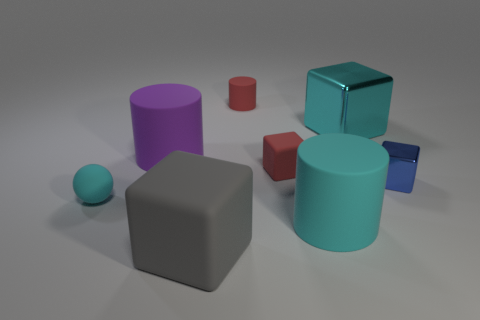Add 2 gray cubes. How many objects exist? 10 Subtract all cylinders. How many objects are left? 5 Subtract all green blocks. Subtract all cyan matte cylinders. How many objects are left? 7 Add 6 red things. How many red things are left? 8 Add 7 blue shiny blocks. How many blue shiny blocks exist? 8 Subtract 0 green spheres. How many objects are left? 8 